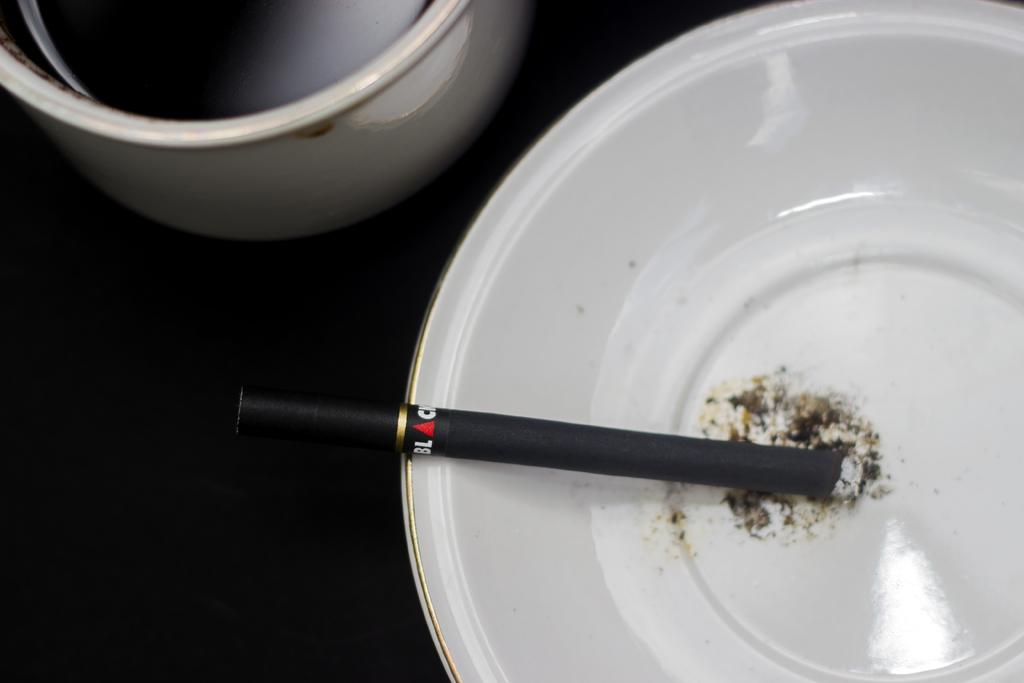What is the color of the cigarette in the image? The cigarette is black in color. What is the color of the bowl containing the cigarette? The bowl is white in color. Where is the container located in the image? The container is in the left top of the image. What is the color of the surface in the image? The surface is black in color. How much wealth does the spy have in the image? There is no indication of a spy or wealth in the image; it only features a black cigarette in a white bowl, a container, and a black surface. 